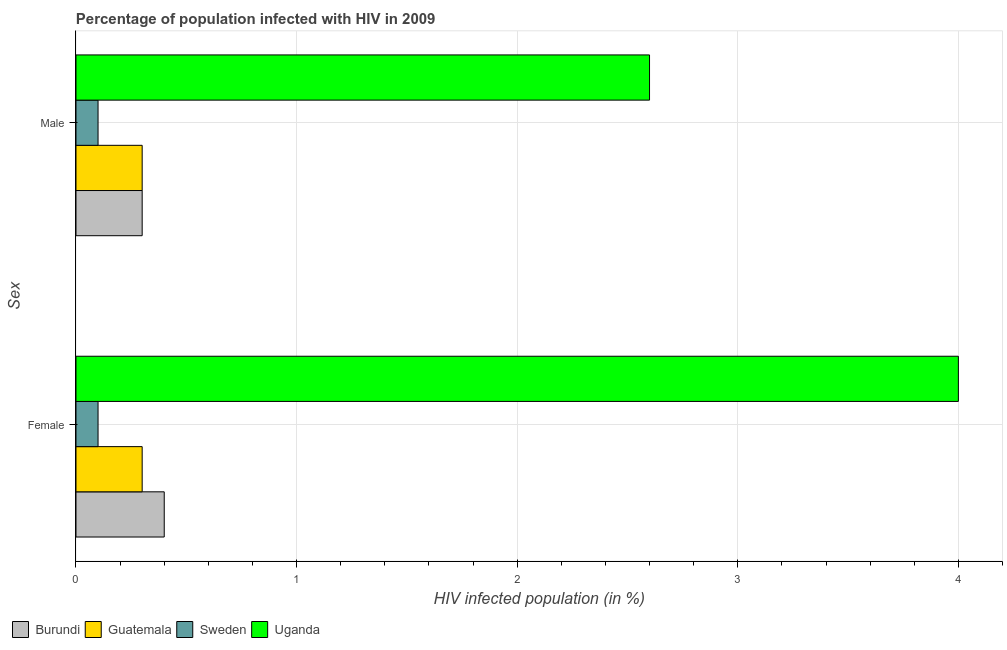How many different coloured bars are there?
Provide a succinct answer. 4. Are the number of bars per tick equal to the number of legend labels?
Make the answer very short. Yes. Are the number of bars on each tick of the Y-axis equal?
Make the answer very short. Yes. How many bars are there on the 1st tick from the bottom?
Provide a succinct answer. 4. What is the label of the 2nd group of bars from the top?
Provide a succinct answer. Female. Across all countries, what is the maximum percentage of females who are infected with hiv?
Offer a very short reply. 4. Across all countries, what is the minimum percentage of females who are infected with hiv?
Provide a short and direct response. 0.1. In which country was the percentage of females who are infected with hiv maximum?
Keep it short and to the point. Uganda. What is the total percentage of females who are infected with hiv in the graph?
Make the answer very short. 4.8. What is the difference between the percentage of females who are infected with hiv in Sweden and that in Burundi?
Your response must be concise. -0.3. What is the difference between the percentage of males who are infected with hiv in Sweden and the percentage of females who are infected with hiv in Burundi?
Your answer should be compact. -0.3. What is the average percentage of males who are infected with hiv per country?
Make the answer very short. 0.82. In how many countries, is the percentage of males who are infected with hiv greater than 3.8 %?
Make the answer very short. 0. What is the ratio of the percentage of females who are infected with hiv in Sweden to that in Uganda?
Offer a terse response. 0.03. What does the 4th bar from the bottom in Female represents?
Make the answer very short. Uganda. Are all the bars in the graph horizontal?
Your response must be concise. Yes. What is the difference between two consecutive major ticks on the X-axis?
Ensure brevity in your answer.  1. Are the values on the major ticks of X-axis written in scientific E-notation?
Make the answer very short. No. Does the graph contain grids?
Make the answer very short. Yes. Where does the legend appear in the graph?
Make the answer very short. Bottom left. How are the legend labels stacked?
Give a very brief answer. Horizontal. What is the title of the graph?
Make the answer very short. Percentage of population infected with HIV in 2009. What is the label or title of the X-axis?
Make the answer very short. HIV infected population (in %). What is the label or title of the Y-axis?
Your answer should be compact. Sex. What is the HIV infected population (in %) in Burundi in Female?
Your answer should be very brief. 0.4. What is the HIV infected population (in %) of Sweden in Male?
Provide a succinct answer. 0.1. What is the HIV infected population (in %) of Uganda in Male?
Ensure brevity in your answer.  2.6. Across all Sex, what is the maximum HIV infected population (in %) of Burundi?
Make the answer very short. 0.4. Across all Sex, what is the minimum HIV infected population (in %) in Guatemala?
Provide a short and direct response. 0.3. Across all Sex, what is the minimum HIV infected population (in %) in Uganda?
Ensure brevity in your answer.  2.6. What is the total HIV infected population (in %) in Sweden in the graph?
Offer a very short reply. 0.2. What is the difference between the HIV infected population (in %) of Burundi in Female and that in Male?
Offer a very short reply. 0.1. What is the difference between the HIV infected population (in %) in Uganda in Female and that in Male?
Offer a terse response. 1.4. What is the difference between the HIV infected population (in %) of Burundi in Female and the HIV infected population (in %) of Uganda in Male?
Make the answer very short. -2.2. What is the difference between the HIV infected population (in %) in Guatemala in Female and the HIV infected population (in %) in Sweden in Male?
Your response must be concise. 0.2. What is the difference between the HIV infected population (in %) in Sweden in Female and the HIV infected population (in %) in Uganda in Male?
Your answer should be compact. -2.5. What is the average HIV infected population (in %) in Burundi per Sex?
Provide a succinct answer. 0.35. What is the average HIV infected population (in %) of Guatemala per Sex?
Your answer should be compact. 0.3. What is the average HIV infected population (in %) of Sweden per Sex?
Ensure brevity in your answer.  0.1. What is the difference between the HIV infected population (in %) in Guatemala and HIV infected population (in %) in Sweden in Female?
Keep it short and to the point. 0.2. What is the difference between the HIV infected population (in %) of Guatemala and HIV infected population (in %) of Uganda in Female?
Keep it short and to the point. -3.7. What is the difference between the HIV infected population (in %) of Burundi and HIV infected population (in %) of Guatemala in Male?
Provide a succinct answer. 0. What is the difference between the HIV infected population (in %) of Guatemala and HIV infected population (in %) of Sweden in Male?
Give a very brief answer. 0.2. What is the difference between the HIV infected population (in %) of Guatemala and HIV infected population (in %) of Uganda in Male?
Offer a terse response. -2.3. What is the difference between the HIV infected population (in %) in Sweden and HIV infected population (in %) in Uganda in Male?
Your answer should be very brief. -2.5. What is the ratio of the HIV infected population (in %) of Burundi in Female to that in Male?
Make the answer very short. 1.33. What is the ratio of the HIV infected population (in %) of Guatemala in Female to that in Male?
Make the answer very short. 1. What is the ratio of the HIV infected population (in %) in Uganda in Female to that in Male?
Make the answer very short. 1.54. What is the difference between the highest and the second highest HIV infected population (in %) in Guatemala?
Give a very brief answer. 0. What is the difference between the highest and the second highest HIV infected population (in %) of Uganda?
Your response must be concise. 1.4. 